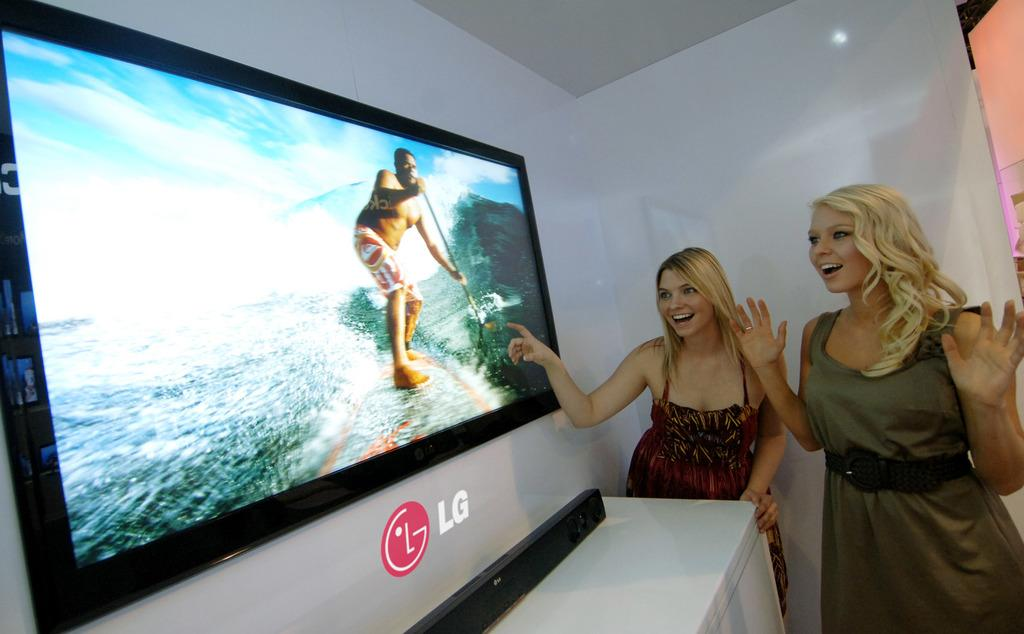<image>
Describe the image concisely. Two blonde women looking at an LG screen that is on the wall. 